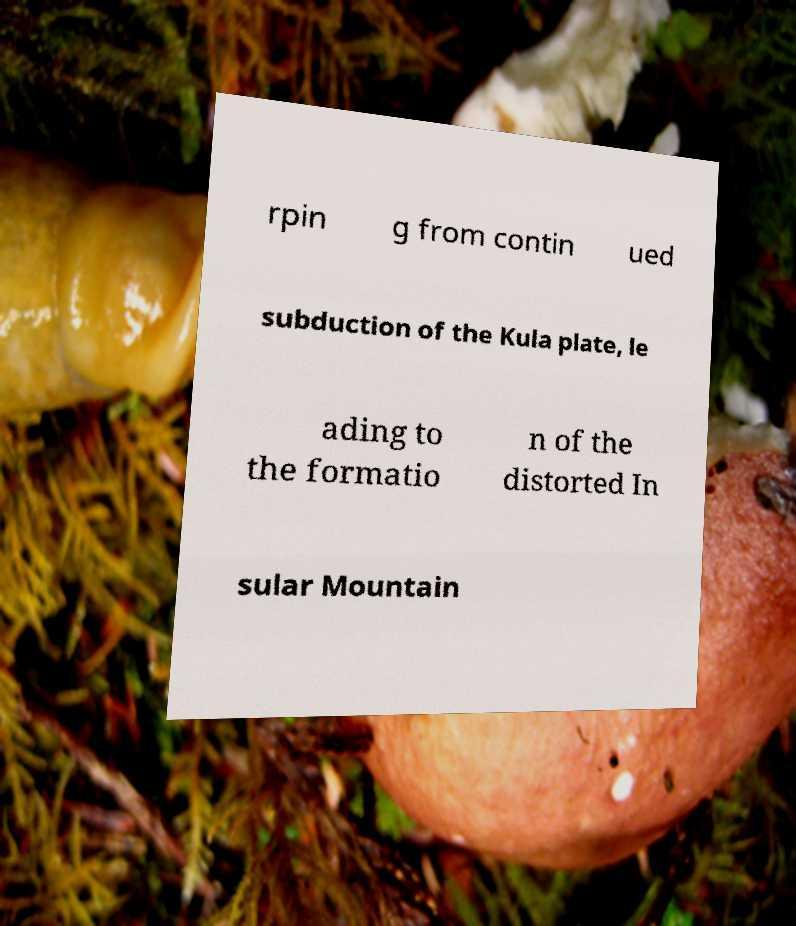Could you assist in decoding the text presented in this image and type it out clearly? rpin g from contin ued subduction of the Kula plate, le ading to the formatio n of the distorted In sular Mountain 